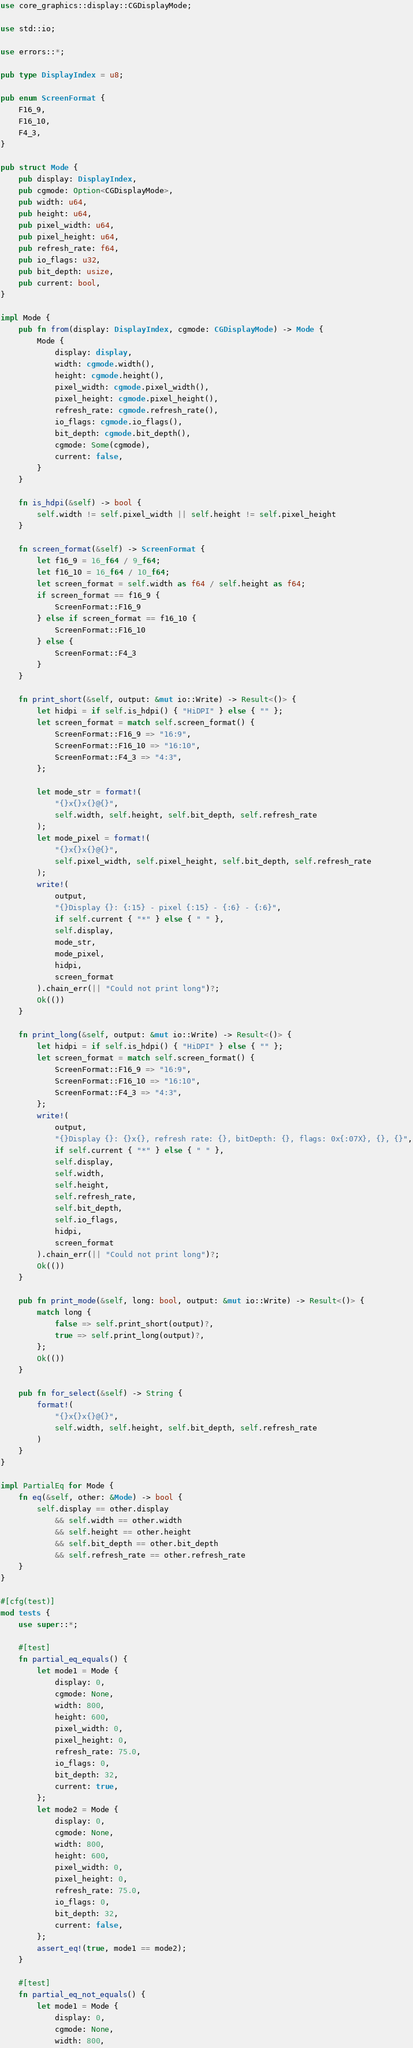<code> <loc_0><loc_0><loc_500><loc_500><_Rust_>use core_graphics::display::CGDisplayMode;

use std::io;

use errors::*;

pub type DisplayIndex = u8;

pub enum ScreenFormat {
    F16_9,
    F16_10,
    F4_3,
}

pub struct Mode {
    pub display: DisplayIndex,
    pub cgmode: Option<CGDisplayMode>,
    pub width: u64,
    pub height: u64,
    pub pixel_width: u64,
    pub pixel_height: u64,
    pub refresh_rate: f64,
    pub io_flags: u32,
    pub bit_depth: usize,
    pub current: bool,
}

impl Mode {
    pub fn from(display: DisplayIndex, cgmode: CGDisplayMode) -> Mode {
        Mode {
            display: display,
            width: cgmode.width(),
            height: cgmode.height(),
            pixel_width: cgmode.pixel_width(),
            pixel_height: cgmode.pixel_height(),
            refresh_rate: cgmode.refresh_rate(),
            io_flags: cgmode.io_flags(),
            bit_depth: cgmode.bit_depth(),
            cgmode: Some(cgmode),
            current: false,
        }
    }

    fn is_hdpi(&self) -> bool {
        self.width != self.pixel_width || self.height != self.pixel_height
    }

    fn screen_format(&self) -> ScreenFormat {
        let f16_9 = 16_f64 / 9_f64;
        let f16_10 = 16_f64 / 10_f64;
        let screen_format = self.width as f64 / self.height as f64;
        if screen_format == f16_9 {
            ScreenFormat::F16_9
        } else if screen_format == f16_10 {
            ScreenFormat::F16_10
        } else {
            ScreenFormat::F4_3
        }
    }

    fn print_short(&self, output: &mut io::Write) -> Result<()> {
        let hidpi = if self.is_hdpi() { "HiDPI" } else { "" };
        let screen_format = match self.screen_format() {
            ScreenFormat::F16_9 => "16:9",
            ScreenFormat::F16_10 => "16:10",
            ScreenFormat::F4_3 => "4:3",
        };

        let mode_str = format!(
            "{}x{}x{}@{}",
            self.width, self.height, self.bit_depth, self.refresh_rate
        );
        let mode_pixel = format!(
            "{}x{}x{}@{}",
            self.pixel_width, self.pixel_height, self.bit_depth, self.refresh_rate
        );
        write!(
            output,
            "{}Display {}: {:15} - pixel {:15} - {:6} - {:6}",
            if self.current { "*" } else { " " },
            self.display,
            mode_str,
            mode_pixel,
            hidpi,
            screen_format
        ).chain_err(|| "Could not print long")?;
        Ok(())
    }

    fn print_long(&self, output: &mut io::Write) -> Result<()> {
        let hidpi = if self.is_hdpi() { "HiDPI" } else { "" };
        let screen_format = match self.screen_format() {
            ScreenFormat::F16_9 => "16:9",
            ScreenFormat::F16_10 => "16:10",
            ScreenFormat::F4_3 => "4:3",
        };
        write!(
            output,
            "{}Display {}: {}x{}, refresh rate: {}, bitDepth: {}, flags: 0x{:07X}, {}, {}",
            if self.current { "*" } else { " " },
            self.display,
            self.width,
            self.height,
            self.refresh_rate,
            self.bit_depth,
            self.io_flags,
            hidpi,
            screen_format
        ).chain_err(|| "Could not print long")?;
        Ok(())
    }

    pub fn print_mode(&self, long: bool, output: &mut io::Write) -> Result<()> {
        match long {
            false => self.print_short(output)?,
            true => self.print_long(output)?,
        };
        Ok(())
    }

    pub fn for_select(&self) -> String {
        format!(
            "{}x{}x{}@{}",
            self.width, self.height, self.bit_depth, self.refresh_rate
        )
    }
}

impl PartialEq for Mode {
    fn eq(&self, other: &Mode) -> bool {
        self.display == other.display
            && self.width == other.width
            && self.height == other.height
            && self.bit_depth == other.bit_depth
            && self.refresh_rate == other.refresh_rate
    }
}

#[cfg(test)]
mod tests {
    use super::*;

    #[test]
    fn partial_eq_equals() {
        let mode1 = Mode {
            display: 0,
            cgmode: None,
            width: 800,
            height: 600,
            pixel_width: 0,
            pixel_height: 0,
            refresh_rate: 75.0,
            io_flags: 0,
            bit_depth: 32,
            current: true,
        };
        let mode2 = Mode {
            display: 0,
            cgmode: None,
            width: 800,
            height: 600,
            pixel_width: 0,
            pixel_height: 0,
            refresh_rate: 75.0,
            io_flags: 0,
            bit_depth: 32,
            current: false,
        };
        assert_eq!(true, mode1 == mode2);
    }

    #[test]
    fn partial_eq_not_equals() {
        let mode1 = Mode {
            display: 0,
            cgmode: None,
            width: 800,</code> 